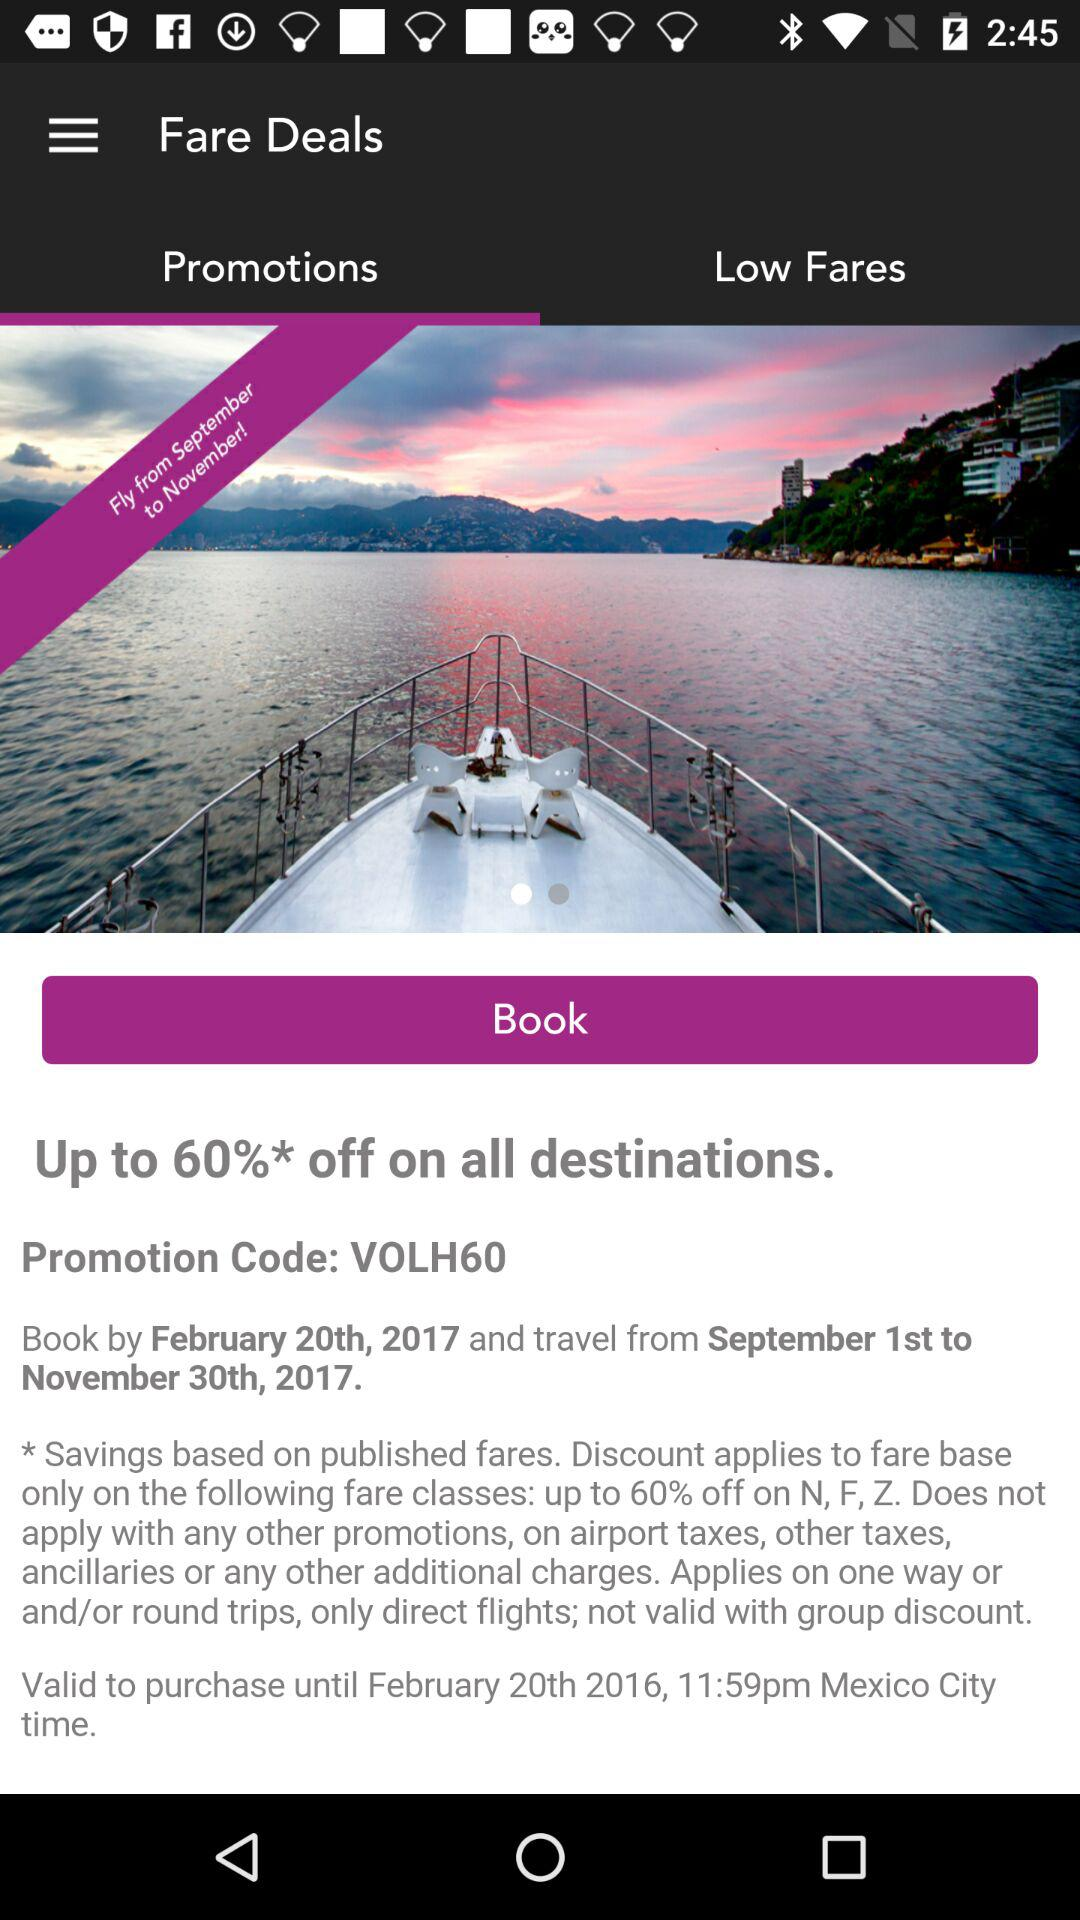What is the promotion code? The promotion code is "VOLH60". 